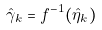Convert formula to latex. <formula><loc_0><loc_0><loc_500><loc_500>\hat { \gamma } _ { k } = f ^ { - 1 } ( \hat { \eta } _ { k } )</formula> 